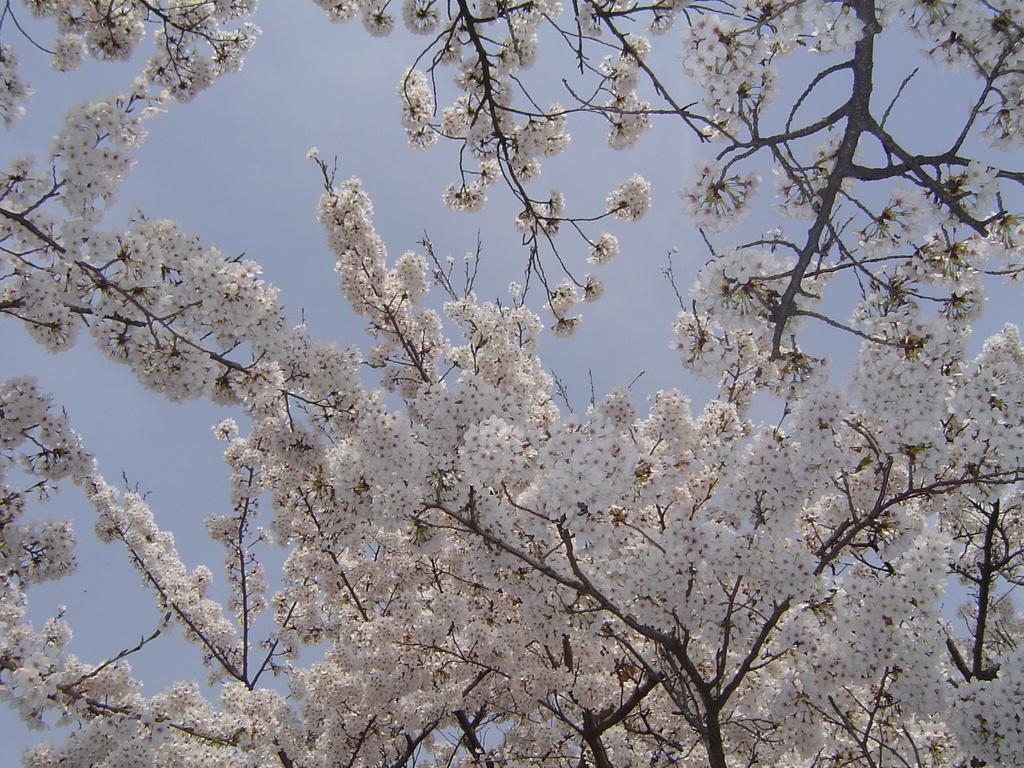Describe this image in one or two sentences. In this image we can see a white color flower tree. In the background, we can see the sky. 